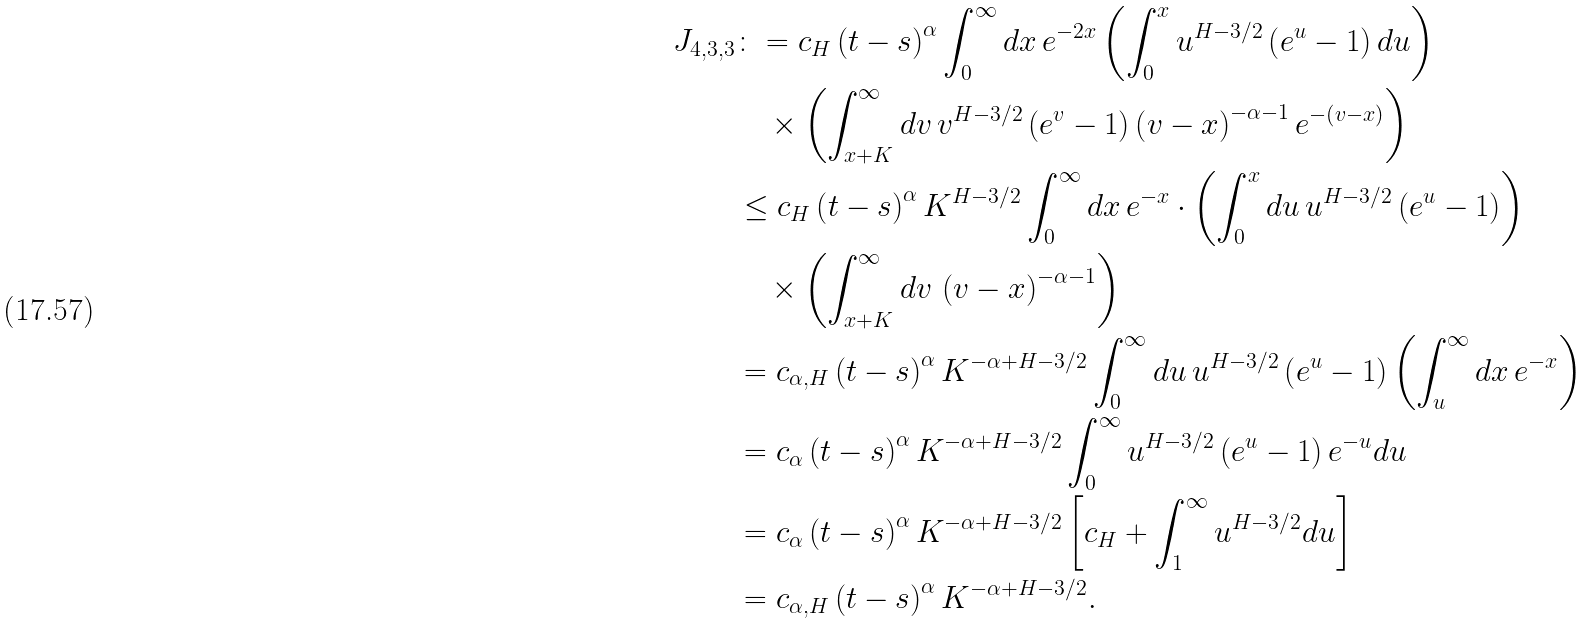<formula> <loc_0><loc_0><loc_500><loc_500>J _ { 4 , 3 , 3 } & \colon = c _ { H } \left ( t - s \right ) ^ { \alpha } \int _ { 0 } ^ { \infty } d x \, e ^ { - 2 x } \left ( \int _ { 0 } ^ { x } u ^ { H - 3 / 2 } \left ( e ^ { u } - 1 \right ) d u \right ) \\ & \quad \times \left ( \int _ { x + K } ^ { \infty } d v \, v ^ { H - 3 / 2 } \left ( e ^ { v } - 1 \right ) \left ( v - x \right ) ^ { - \alpha - 1 } e ^ { - \left ( v - x \right ) } \right ) \\ & \leq c _ { H } \left ( t - s \right ) ^ { \alpha } K ^ { H - 3 / 2 } \int _ { 0 } ^ { \infty } d x \, e ^ { - x } \cdot \left ( \int _ { 0 } ^ { x } d u \, u ^ { H - 3 / 2 } \left ( e ^ { u } - 1 \right ) \right ) \\ & \quad \times \left ( \int _ { x + K } ^ { \infty } d v \, \left ( v - x \right ) ^ { - \alpha - 1 } \right ) \\ & = c _ { \alpha , H } \left ( t - s \right ) ^ { \alpha } K ^ { - \alpha + H - 3 / 2 } \int _ { 0 } ^ { \infty } d u \, u ^ { H - 3 / 2 } \left ( e ^ { u } - 1 \right ) \left ( \int _ { u } ^ { \infty } d x \, e ^ { - x } \right ) \\ & = c _ { \alpha } \left ( t - s \right ) ^ { \alpha } K ^ { - \alpha + H - 3 / 2 } \int _ { 0 } ^ { \infty } u ^ { H - 3 / 2 } \left ( e ^ { u } - 1 \right ) e ^ { - u } d u \\ & = c _ { \alpha } \left ( t - s \right ) ^ { \alpha } K ^ { - \alpha + H - 3 / 2 } \left [ c _ { H } + \int _ { 1 } ^ { \infty } u ^ { H - 3 / 2 } d u \right ] \\ & = c _ { \alpha , H } \left ( t - s \right ) ^ { \alpha } K ^ { - \alpha + H - 3 / 2 } .</formula> 